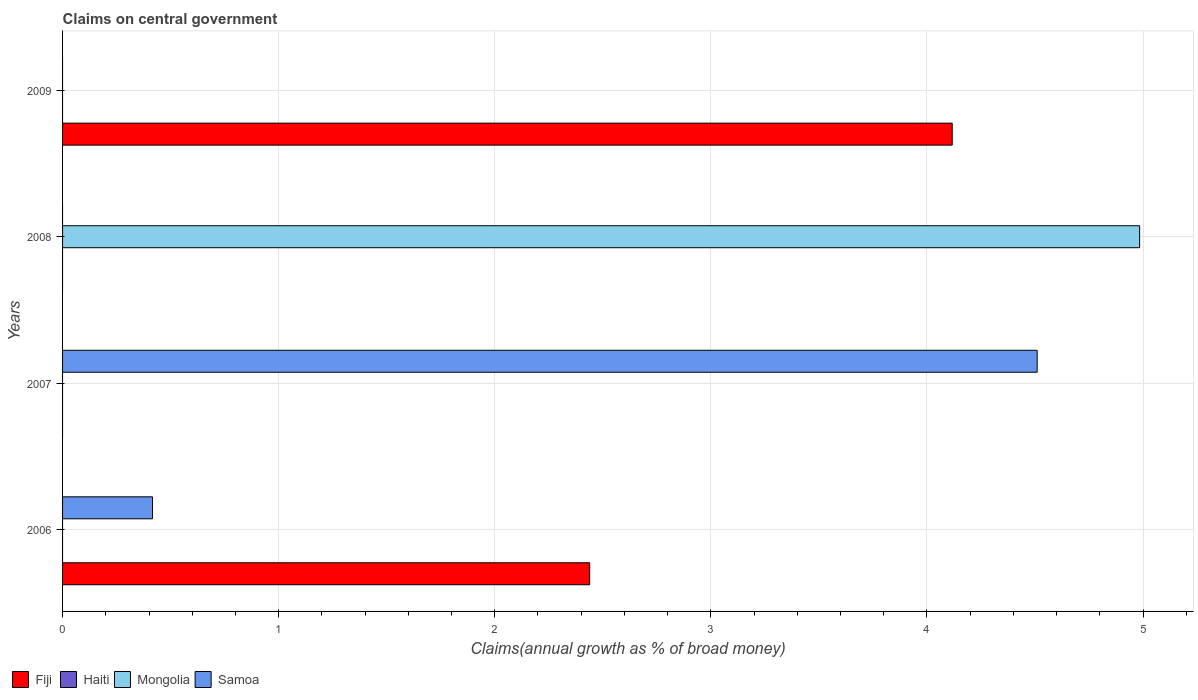How many different coloured bars are there?
Your answer should be compact. 3. Are the number of bars per tick equal to the number of legend labels?
Your answer should be compact. No. How many bars are there on the 4th tick from the bottom?
Your answer should be compact. 1. What is the label of the 3rd group of bars from the top?
Provide a succinct answer. 2007. What is the percentage of broad money claimed on centeral government in Haiti in 2007?
Offer a very short reply. 0. Across all years, what is the maximum percentage of broad money claimed on centeral government in Mongolia?
Offer a terse response. 4.98. Across all years, what is the minimum percentage of broad money claimed on centeral government in Samoa?
Offer a terse response. 0. What is the total percentage of broad money claimed on centeral government in Samoa in the graph?
Provide a succinct answer. 4.93. What is the average percentage of broad money claimed on centeral government in Samoa per year?
Give a very brief answer. 1.23. In how many years, is the percentage of broad money claimed on centeral government in Fiji greater than 0.6000000000000001 %?
Offer a terse response. 2. What is the difference between the highest and the lowest percentage of broad money claimed on centeral government in Samoa?
Keep it short and to the point. 4.51. In how many years, is the percentage of broad money claimed on centeral government in Haiti greater than the average percentage of broad money claimed on centeral government in Haiti taken over all years?
Offer a very short reply. 0. Is it the case that in every year, the sum of the percentage of broad money claimed on centeral government in Fiji and percentage of broad money claimed on centeral government in Haiti is greater than the percentage of broad money claimed on centeral government in Samoa?
Make the answer very short. No. Are the values on the major ticks of X-axis written in scientific E-notation?
Make the answer very short. No. Does the graph contain grids?
Your response must be concise. Yes. Where does the legend appear in the graph?
Ensure brevity in your answer.  Bottom left. How many legend labels are there?
Offer a very short reply. 4. What is the title of the graph?
Ensure brevity in your answer.  Claims on central government. What is the label or title of the X-axis?
Provide a succinct answer. Claims(annual growth as % of broad money). What is the label or title of the Y-axis?
Offer a very short reply. Years. What is the Claims(annual growth as % of broad money) of Fiji in 2006?
Offer a terse response. 2.44. What is the Claims(annual growth as % of broad money) of Haiti in 2006?
Provide a short and direct response. 0. What is the Claims(annual growth as % of broad money) in Samoa in 2006?
Your response must be concise. 0.42. What is the Claims(annual growth as % of broad money) of Fiji in 2007?
Your response must be concise. 0. What is the Claims(annual growth as % of broad money) of Haiti in 2007?
Make the answer very short. 0. What is the Claims(annual growth as % of broad money) in Samoa in 2007?
Keep it short and to the point. 4.51. What is the Claims(annual growth as % of broad money) in Fiji in 2008?
Make the answer very short. 0. What is the Claims(annual growth as % of broad money) of Mongolia in 2008?
Make the answer very short. 4.98. What is the Claims(annual growth as % of broad money) of Samoa in 2008?
Your answer should be compact. 0. What is the Claims(annual growth as % of broad money) in Fiji in 2009?
Your answer should be compact. 4.12. What is the Claims(annual growth as % of broad money) of Mongolia in 2009?
Provide a short and direct response. 0. What is the Claims(annual growth as % of broad money) in Samoa in 2009?
Give a very brief answer. 0. Across all years, what is the maximum Claims(annual growth as % of broad money) of Fiji?
Your response must be concise. 4.12. Across all years, what is the maximum Claims(annual growth as % of broad money) in Mongolia?
Provide a short and direct response. 4.98. Across all years, what is the maximum Claims(annual growth as % of broad money) of Samoa?
Your response must be concise. 4.51. Across all years, what is the minimum Claims(annual growth as % of broad money) of Fiji?
Your answer should be compact. 0. What is the total Claims(annual growth as % of broad money) of Fiji in the graph?
Offer a very short reply. 6.56. What is the total Claims(annual growth as % of broad money) of Mongolia in the graph?
Ensure brevity in your answer.  4.98. What is the total Claims(annual growth as % of broad money) of Samoa in the graph?
Offer a terse response. 4.93. What is the difference between the Claims(annual growth as % of broad money) of Samoa in 2006 and that in 2007?
Make the answer very short. -4.09. What is the difference between the Claims(annual growth as % of broad money) in Fiji in 2006 and that in 2009?
Keep it short and to the point. -1.68. What is the difference between the Claims(annual growth as % of broad money) in Fiji in 2006 and the Claims(annual growth as % of broad money) in Samoa in 2007?
Provide a succinct answer. -2.07. What is the difference between the Claims(annual growth as % of broad money) of Fiji in 2006 and the Claims(annual growth as % of broad money) of Mongolia in 2008?
Provide a short and direct response. -2.55. What is the average Claims(annual growth as % of broad money) in Fiji per year?
Offer a terse response. 1.64. What is the average Claims(annual growth as % of broad money) in Haiti per year?
Offer a terse response. 0. What is the average Claims(annual growth as % of broad money) in Mongolia per year?
Ensure brevity in your answer.  1.25. What is the average Claims(annual growth as % of broad money) in Samoa per year?
Offer a very short reply. 1.23. In the year 2006, what is the difference between the Claims(annual growth as % of broad money) of Fiji and Claims(annual growth as % of broad money) of Samoa?
Keep it short and to the point. 2.02. What is the ratio of the Claims(annual growth as % of broad money) in Samoa in 2006 to that in 2007?
Provide a short and direct response. 0.09. What is the ratio of the Claims(annual growth as % of broad money) of Fiji in 2006 to that in 2009?
Offer a very short reply. 0.59. What is the difference between the highest and the lowest Claims(annual growth as % of broad money) in Fiji?
Offer a very short reply. 4.12. What is the difference between the highest and the lowest Claims(annual growth as % of broad money) in Mongolia?
Your answer should be compact. 4.98. What is the difference between the highest and the lowest Claims(annual growth as % of broad money) of Samoa?
Your answer should be very brief. 4.51. 